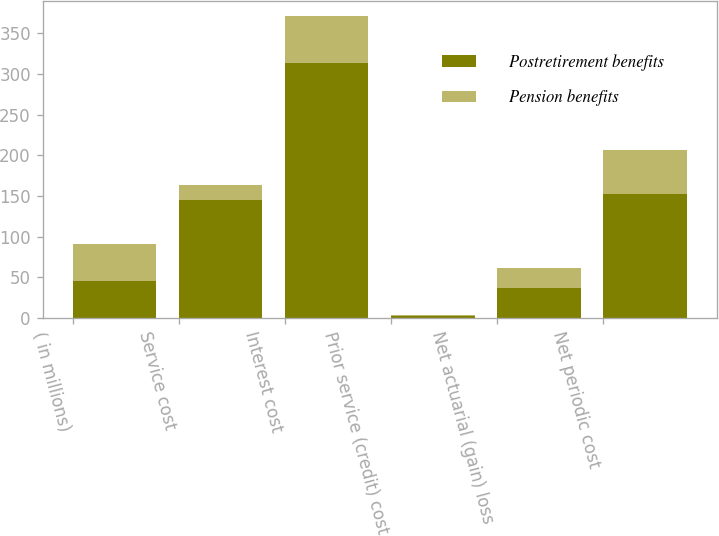Convert chart to OTSL. <chart><loc_0><loc_0><loc_500><loc_500><stacked_bar_chart><ecel><fcel>( in millions)<fcel>Service cost<fcel>Interest cost<fcel>Prior service (credit) cost<fcel>Net actuarial (gain) loss<fcel>Net periodic cost<nl><fcel>Postretirement benefits<fcel>45.5<fcel>145<fcel>313<fcel>2<fcel>37<fcel>153<nl><fcel>Pension benefits<fcel>45.5<fcel>18<fcel>58<fcel>2<fcel>24<fcel>54<nl></chart> 